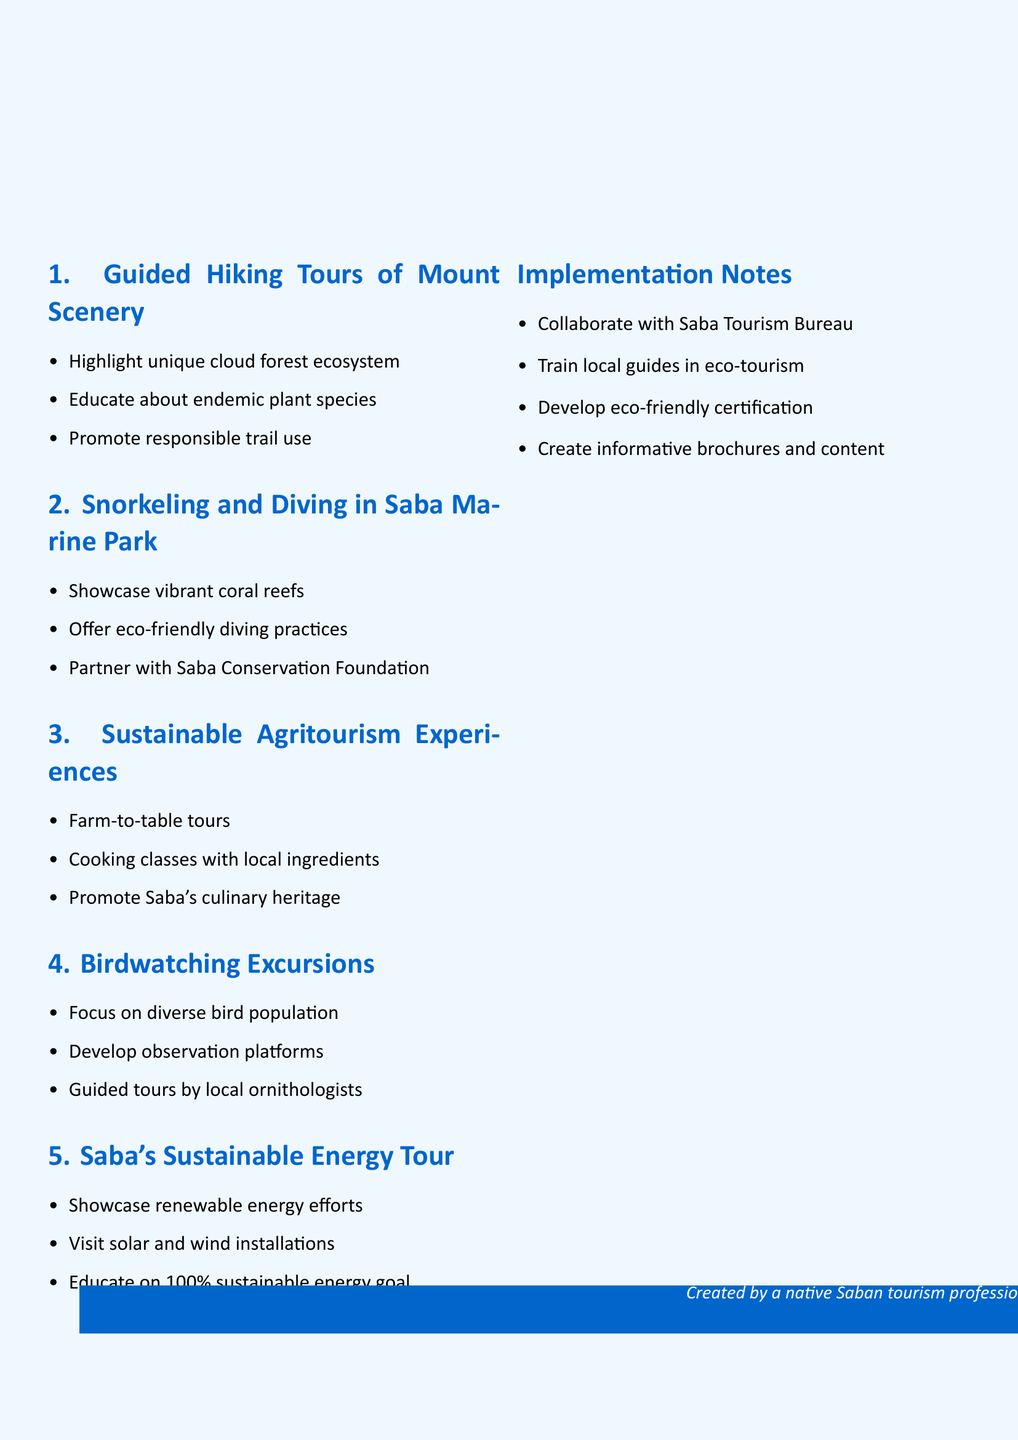What is the main topic of the document? The main topic is summarized in the title of the document, reflecting its focus on eco-friendly tourist activities in a specific location.
Answer: Eco-friendly Tourist Activities to Promote Saba's Natural Beauty How many eco-friendly tourist activities are listed? The number of activities is indicated by the sections numbered in the document.
Answer: Five What is the first activity mentioned? The activities are presented in a numbered list, with the first being the top item.
Answer: Guided Hiking Tours of Mount Scenery Which organization is mentioned as a partner for diving programs? The partnership details are specified under the diving activity, naming the organization involved.
Answer: Saba Conservation Foundation What is the goal of Saba’s Sustainable Energy Tour? The goal is stated as part of the educational aspect of the energy tour.
Answer: 100% sustainable energy What aspect of Saba's ecosystem is highlighted in hiking tours? The specific ecosystem referenced in the hiking tour details provides insight into Saba's unique environment.
Answer: Cloud forest ecosystem How will local guides be trained according to the implementation notes? The notes specify that training will focus on a particular area of expertise for the guides.
Answer: Eco-tourism practices and conservation What culinary aspect is featured in Sustainable Agritourism Experiences? The document indicates a focus on local ingredients as part of the culinary experience.
Answer: Locally grown ingredients What type of bird is specifically mentioned in the birdwatching excursions? The bird mentioned is pointed out in the details for birdwatching excursions, demonstrating Saba's unique wildlife.
Answer: Saba Bush Wren 